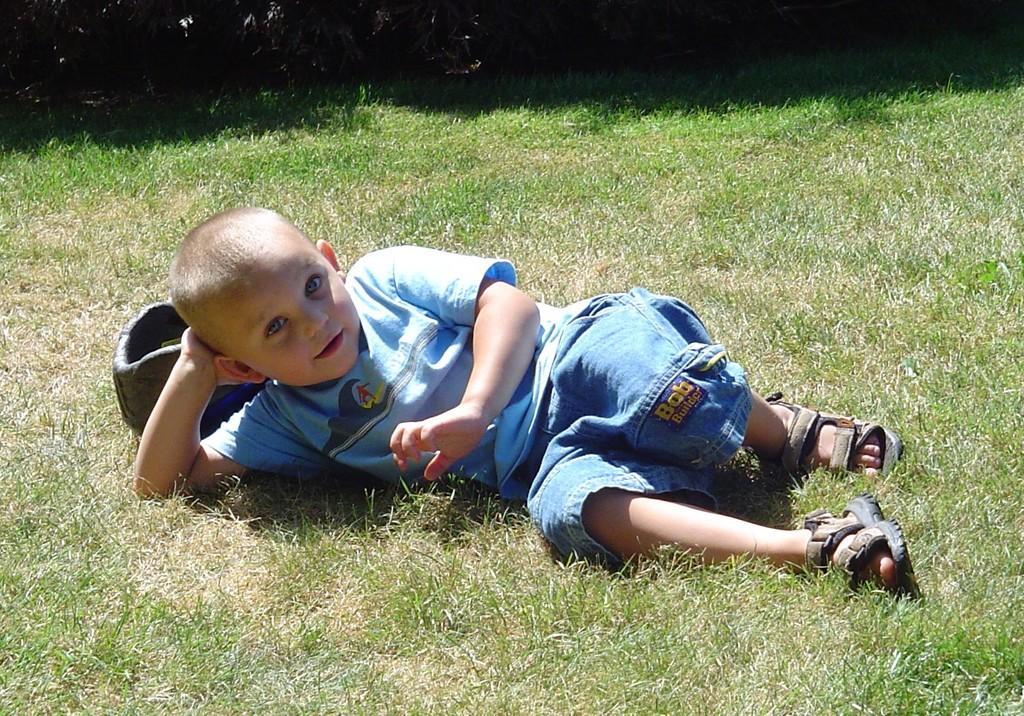Can you describe this image briefly? In this picture I can see a boy lying on the ground and I can see grass on the ground. 